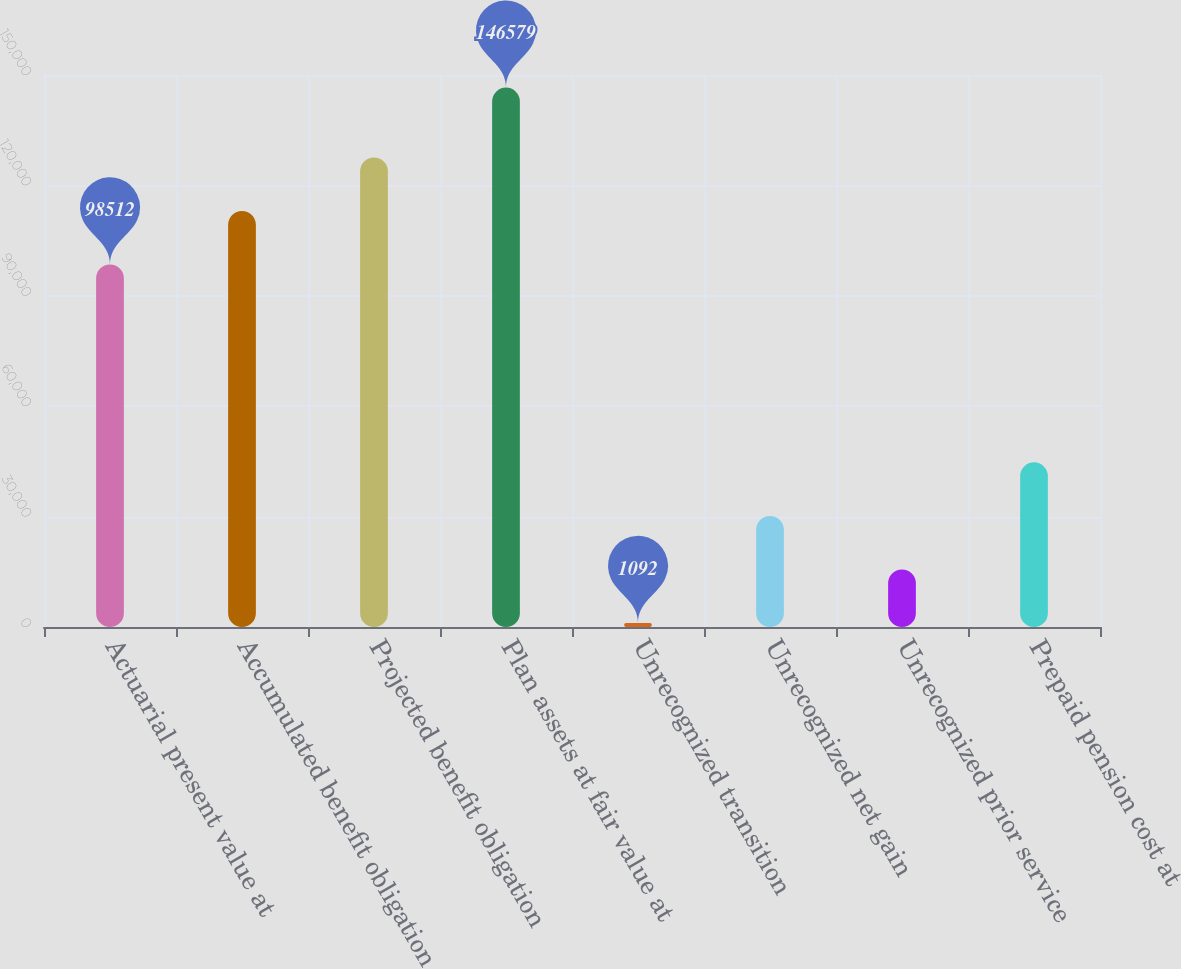Convert chart. <chart><loc_0><loc_0><loc_500><loc_500><bar_chart><fcel>Actuarial present value at<fcel>Accumulated benefit obligation<fcel>Projected benefit obligation<fcel>Plan assets at fair value at<fcel>Unrecognized transition<fcel>Unrecognized net gain<fcel>Unrecognized prior service<fcel>Prepaid pension cost at<nl><fcel>98512<fcel>113061<fcel>127609<fcel>146579<fcel>1092<fcel>30189.4<fcel>15640.7<fcel>44738.1<nl></chart> 